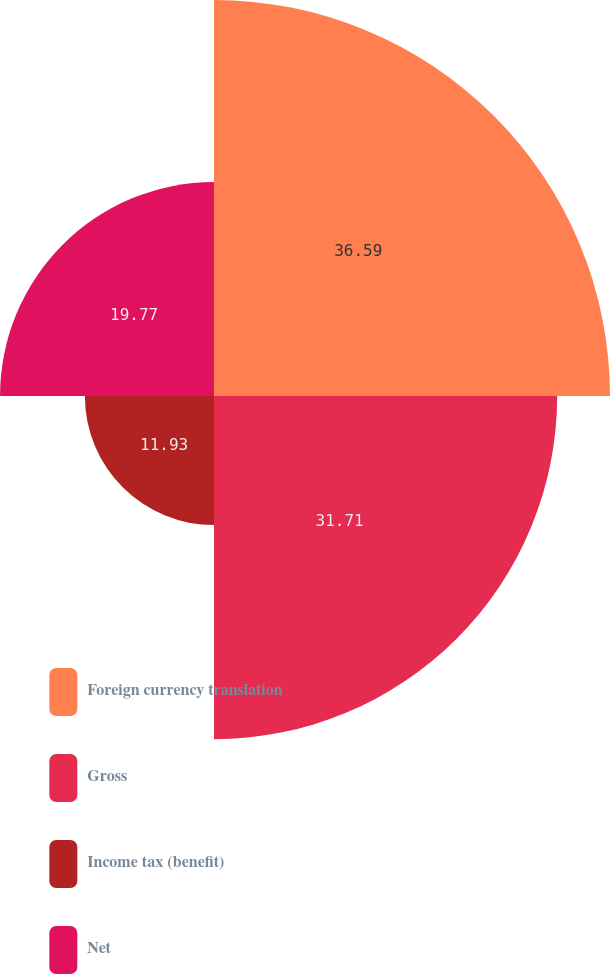Convert chart. <chart><loc_0><loc_0><loc_500><loc_500><pie_chart><fcel>Foreign currency translation<fcel>Gross<fcel>Income tax (benefit)<fcel>Net<nl><fcel>36.59%<fcel>31.71%<fcel>11.93%<fcel>19.77%<nl></chart> 